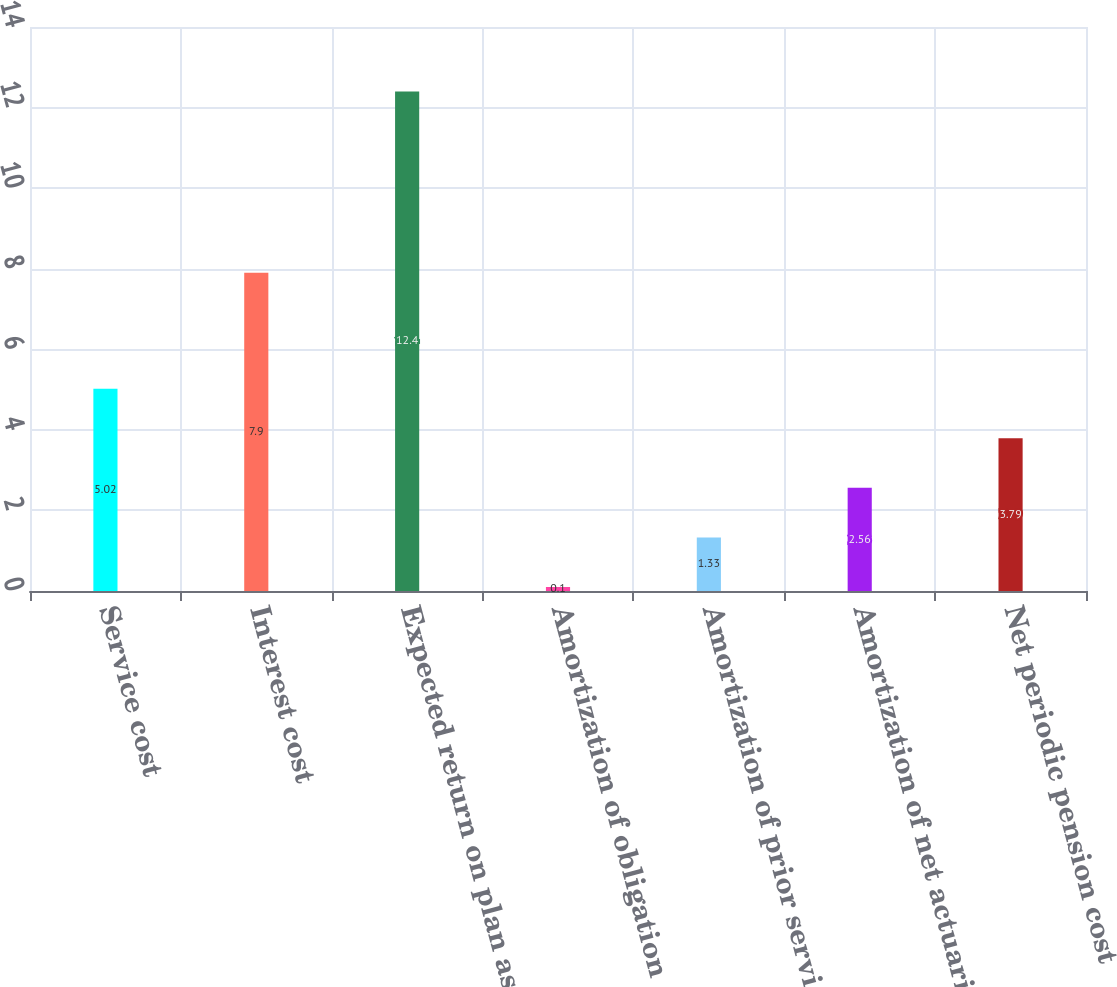<chart> <loc_0><loc_0><loc_500><loc_500><bar_chart><fcel>Service cost<fcel>Interest cost<fcel>Expected return on plan assets<fcel>Amortization of obligation<fcel>Amortization of prior service<fcel>Amortization of net actuarial<fcel>Net periodic pension cost<nl><fcel>5.02<fcel>7.9<fcel>12.4<fcel>0.1<fcel>1.33<fcel>2.56<fcel>3.79<nl></chart> 